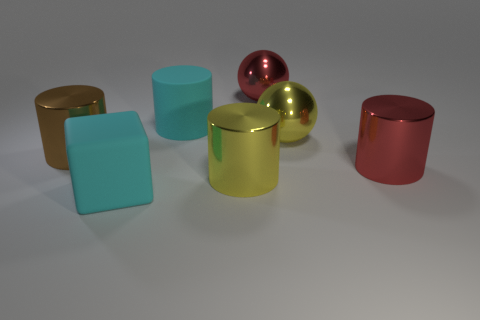Add 2 cyan rubber blocks. How many objects exist? 9 Subtract all big red metal cylinders. How many cylinders are left? 3 Subtract 1 spheres. How many spheres are left? 1 Add 4 big cyan matte cylinders. How many big cyan matte cylinders are left? 5 Add 5 green metallic blocks. How many green metallic blocks exist? 5 Subtract all red cylinders. How many cylinders are left? 3 Subtract 1 red balls. How many objects are left? 6 Subtract all blocks. How many objects are left? 6 Subtract all cyan cylinders. Subtract all gray spheres. How many cylinders are left? 3 Subtract all big yellow shiny cylinders. Subtract all large brown cylinders. How many objects are left? 5 